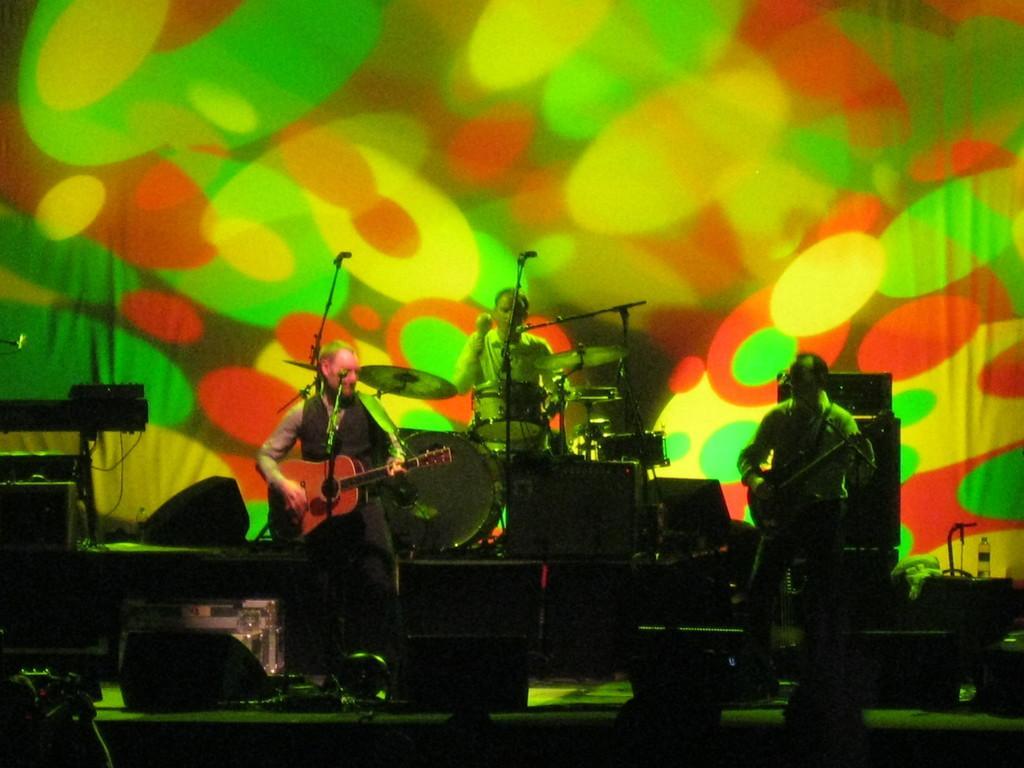How would you summarize this image in a sentence or two? In the middle there is a man he is playing drums. on the right there is a man he is playing guitar. on the left there is a man he is playing guitar. I think this is a stage performance. In the background there is a poster. 